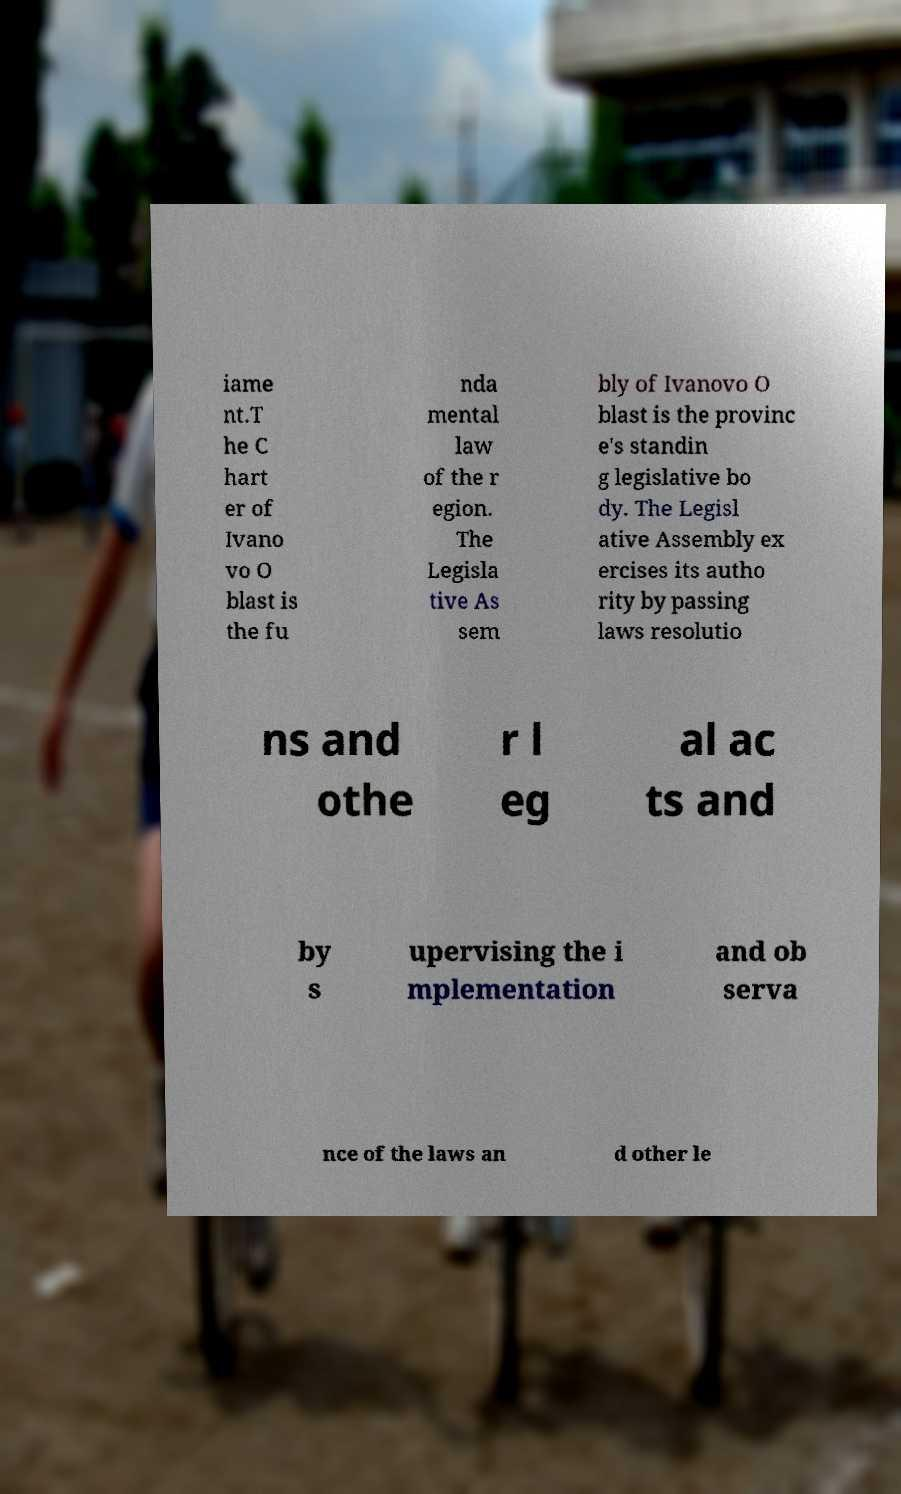I need the written content from this picture converted into text. Can you do that? iame nt.T he C hart er of Ivano vo O blast is the fu nda mental law of the r egion. The Legisla tive As sem bly of Ivanovo O blast is the provinc e's standin g legislative bo dy. The Legisl ative Assembly ex ercises its autho rity by passing laws resolutio ns and othe r l eg al ac ts and by s upervising the i mplementation and ob serva nce of the laws an d other le 